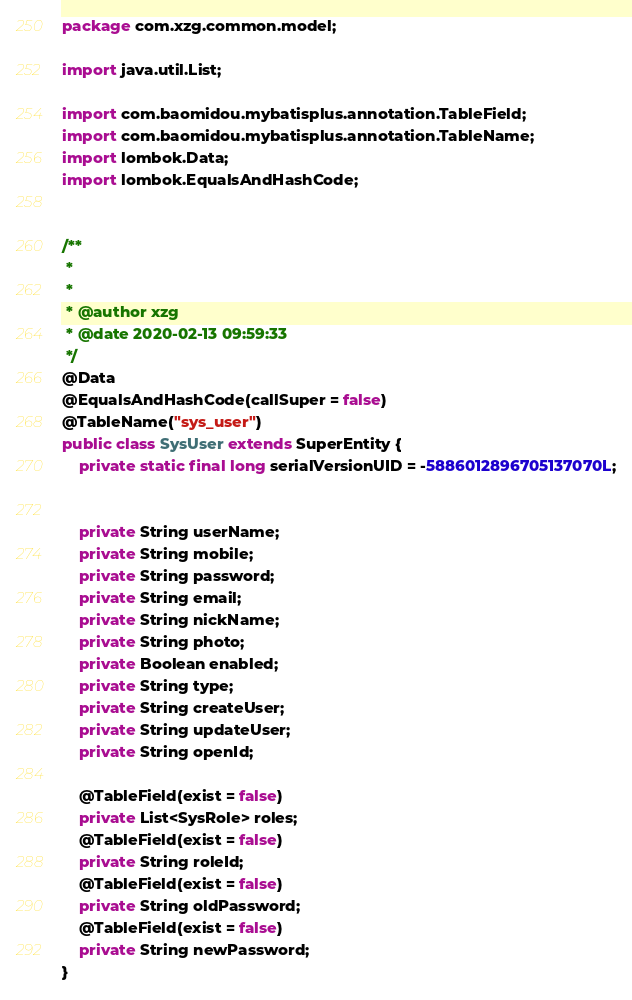<code> <loc_0><loc_0><loc_500><loc_500><_Java_>package com.xzg.common.model;

import java.util.List;

import com.baomidou.mybatisplus.annotation.TableField;
import com.baomidou.mybatisplus.annotation.TableName;
import lombok.Data;
import lombok.EqualsAndHashCode;


/**
 *
 *
 * @author xzg
 * @date 2020-02-13 09:59:33
 */
@Data
@EqualsAndHashCode(callSuper = false)
@TableName("sys_user")
public class SysUser extends SuperEntity {
	private static final long serialVersionUID = -5886012896705137070L;


	private String userName;
	private String mobile;
	private String password;
	private String email;
	private String nickName;
	private String photo;
	private Boolean enabled;
	private String type;
	private String createUser;
	private String updateUser;
	private String openId;

	@TableField(exist = false)
	private List<SysRole> roles;
	@TableField(exist = false)
	private String roleId;
	@TableField(exist = false)
	private String oldPassword;
	@TableField(exist = false)
	private String newPassword;
}
</code> 